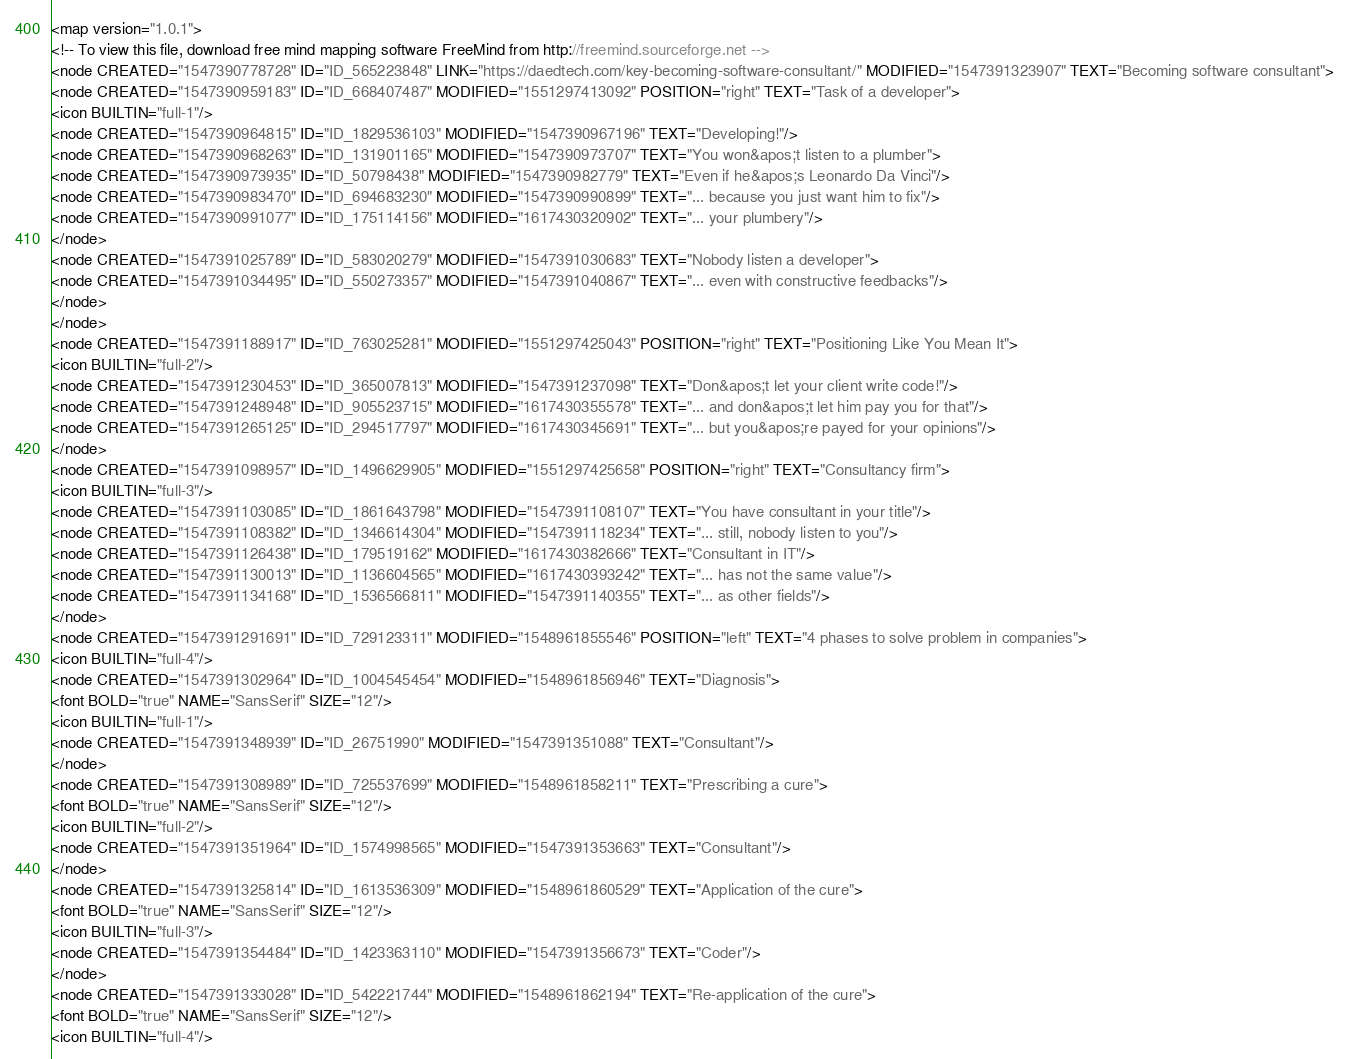<code> <loc_0><loc_0><loc_500><loc_500><_ObjectiveC_><map version="1.0.1">
<!-- To view this file, download free mind mapping software FreeMind from http://freemind.sourceforge.net -->
<node CREATED="1547390778728" ID="ID_565223848" LINK="https://daedtech.com/key-becoming-software-consultant/" MODIFIED="1547391323907" TEXT="Becoming software consultant">
<node CREATED="1547390959183" ID="ID_668407487" MODIFIED="1551297413092" POSITION="right" TEXT="Task of a developer">
<icon BUILTIN="full-1"/>
<node CREATED="1547390964815" ID="ID_1829536103" MODIFIED="1547390967196" TEXT="Developing!"/>
<node CREATED="1547390968263" ID="ID_131901165" MODIFIED="1547390973707" TEXT="You won&apos;t listen to a plumber">
<node CREATED="1547390973935" ID="ID_50798438" MODIFIED="1547390982779" TEXT="Even if he&apos;s Leonardo Da Vinci"/>
<node CREATED="1547390983470" ID="ID_694683230" MODIFIED="1547390990899" TEXT="... because you just want him to fix"/>
<node CREATED="1547390991077" ID="ID_175114156" MODIFIED="1617430320902" TEXT="... your plumbery"/>
</node>
<node CREATED="1547391025789" ID="ID_583020279" MODIFIED="1547391030683" TEXT="Nobody listen a developer">
<node CREATED="1547391034495" ID="ID_550273357" MODIFIED="1547391040867" TEXT="... even with constructive feedbacks"/>
</node>
</node>
<node CREATED="1547391188917" ID="ID_763025281" MODIFIED="1551297425043" POSITION="right" TEXT="Positioning Like You Mean It">
<icon BUILTIN="full-2"/>
<node CREATED="1547391230453" ID="ID_365007813" MODIFIED="1547391237098" TEXT="Don&apos;t let your client write code!"/>
<node CREATED="1547391248948" ID="ID_905523715" MODIFIED="1617430355578" TEXT="... and don&apos;t let him pay you for that"/>
<node CREATED="1547391265125" ID="ID_294517797" MODIFIED="1617430345691" TEXT="... but you&apos;re payed for your opinions"/>
</node>
<node CREATED="1547391098957" ID="ID_1496629905" MODIFIED="1551297425658" POSITION="right" TEXT="Consultancy firm">
<icon BUILTIN="full-3"/>
<node CREATED="1547391103085" ID="ID_1861643798" MODIFIED="1547391108107" TEXT="You have consultant in your title"/>
<node CREATED="1547391108382" ID="ID_1346614304" MODIFIED="1547391118234" TEXT="... still, nobody listen to you"/>
<node CREATED="1547391126438" ID="ID_179519162" MODIFIED="1617430382666" TEXT="Consultant in IT"/>
<node CREATED="1547391130013" ID="ID_1136604565" MODIFIED="1617430393242" TEXT="... has not the same value"/>
<node CREATED="1547391134168" ID="ID_1536566811" MODIFIED="1547391140355" TEXT="... as other fields"/>
</node>
<node CREATED="1547391291691" ID="ID_729123311" MODIFIED="1548961855546" POSITION="left" TEXT="4 phases to solve problem in companies">
<icon BUILTIN="full-4"/>
<node CREATED="1547391302964" ID="ID_1004545454" MODIFIED="1548961856946" TEXT="Diagnosis">
<font BOLD="true" NAME="SansSerif" SIZE="12"/>
<icon BUILTIN="full-1"/>
<node CREATED="1547391348939" ID="ID_26751990" MODIFIED="1547391351088" TEXT="Consultant"/>
</node>
<node CREATED="1547391308989" ID="ID_725537699" MODIFIED="1548961858211" TEXT="Prescribing a cure">
<font BOLD="true" NAME="SansSerif" SIZE="12"/>
<icon BUILTIN="full-2"/>
<node CREATED="1547391351964" ID="ID_1574998565" MODIFIED="1547391353663" TEXT="Consultant"/>
</node>
<node CREATED="1547391325814" ID="ID_1613536309" MODIFIED="1548961860529" TEXT="Application of the cure">
<font BOLD="true" NAME="SansSerif" SIZE="12"/>
<icon BUILTIN="full-3"/>
<node CREATED="1547391354484" ID="ID_1423363110" MODIFIED="1547391356673" TEXT="Coder"/>
</node>
<node CREATED="1547391333028" ID="ID_542221744" MODIFIED="1548961862194" TEXT="Re-application of the cure">
<font BOLD="true" NAME="SansSerif" SIZE="12"/>
<icon BUILTIN="full-4"/></code> 